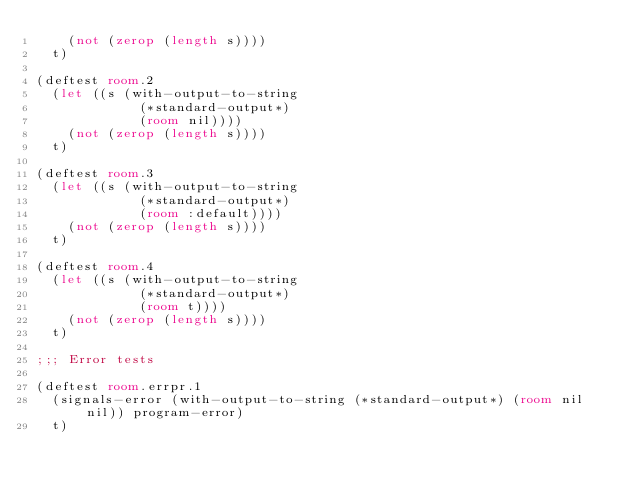<code> <loc_0><loc_0><loc_500><loc_500><_Lisp_>    (not (zerop (length s))))
  t)

(deftest room.2
  (let ((s (with-output-to-string
             (*standard-output*)
             (room nil))))
    (not (zerop (length s))))
  t)

(deftest room.3
  (let ((s (with-output-to-string
             (*standard-output*)
             (room :default))))
    (not (zerop (length s))))
  t)

(deftest room.4
  (let ((s (with-output-to-string
             (*standard-output*)
             (room t))))
    (not (zerop (length s))))
  t)

;;; Error tests

(deftest room.errpr.1
  (signals-error (with-output-to-string (*standard-output*) (room nil nil)) program-error)
  t)






</code> 